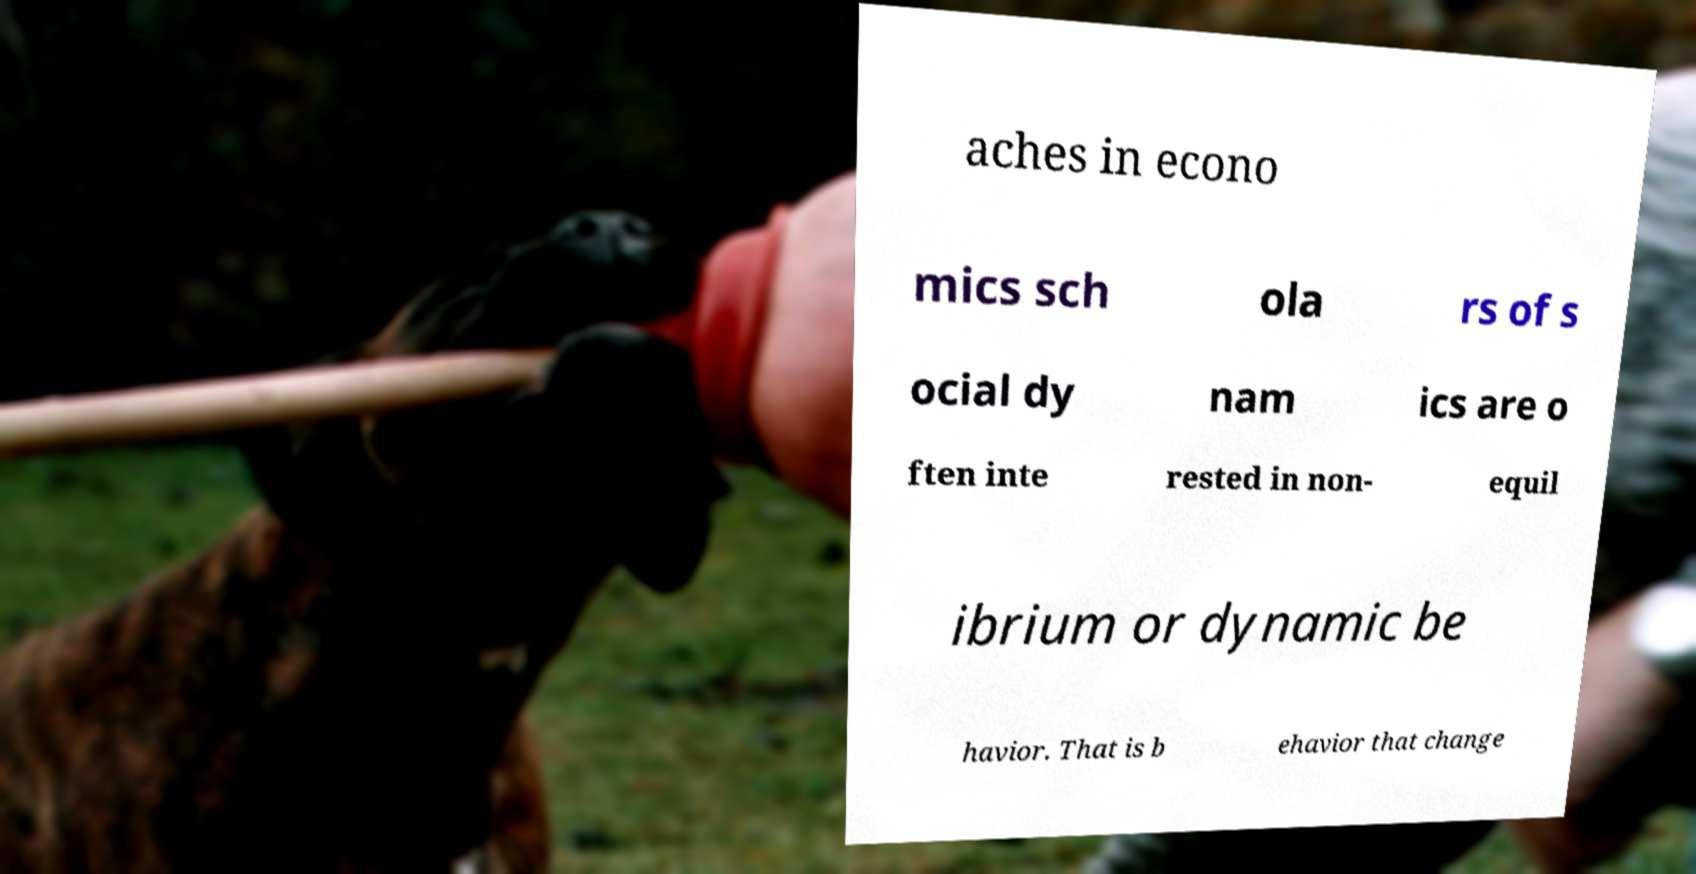Can you read and provide the text displayed in the image?This photo seems to have some interesting text. Can you extract and type it out for me? aches in econo mics sch ola rs of s ocial dy nam ics are o ften inte rested in non- equil ibrium or dynamic be havior. That is b ehavior that change 